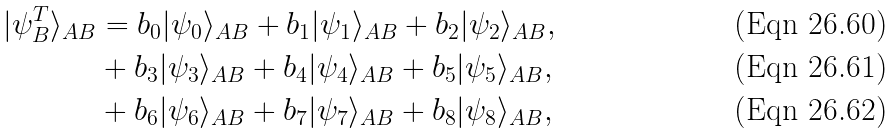<formula> <loc_0><loc_0><loc_500><loc_500>| \psi ^ { T } _ { B } \rangle _ { A B } & = b _ { 0 } | { \psi _ { 0 } } \rangle _ { A B } + b _ { 1 } | { \psi _ { 1 } } \rangle _ { A B } + b _ { 2 } | { \psi _ { 2 } } \rangle _ { A B } , \\ & + b _ { 3 } | { \psi _ { 3 } } \rangle _ { A B } + b _ { 4 } | { \psi _ { 4 } } \rangle _ { A B } + b _ { 5 } | { \psi _ { 5 } } \rangle _ { A B } , \\ & + b _ { 6 } | { \psi _ { 6 } } \rangle _ { A B } + b _ { 7 } | { \psi _ { 7 } } \rangle _ { A B } + b _ { 8 } | { \psi _ { 8 } } \rangle _ { A B } ,</formula> 